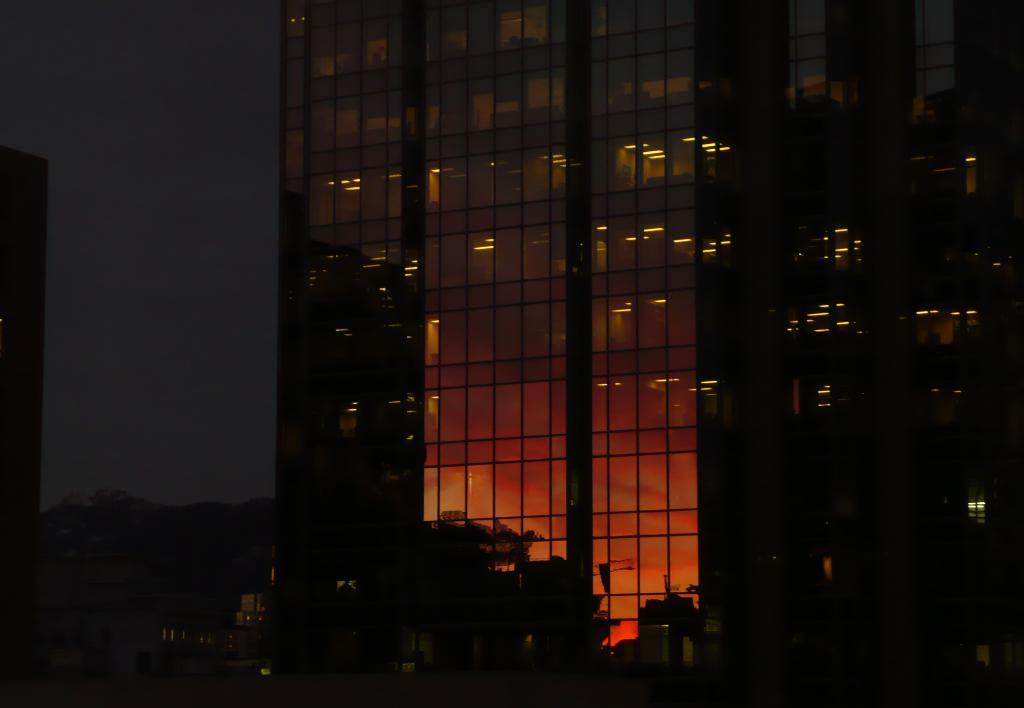What type of structures are visible in the image? There are buildings with lights in the image. What type of vegetation is at the bottom of the image? There are trees at the bottom of the image. What is visible at the top of the image? The sky is visible at the top of the image. Where is the locket located in the image? There is no locket present in the image. What type of border surrounds the image? The provided facts do not mention a border around the image. 